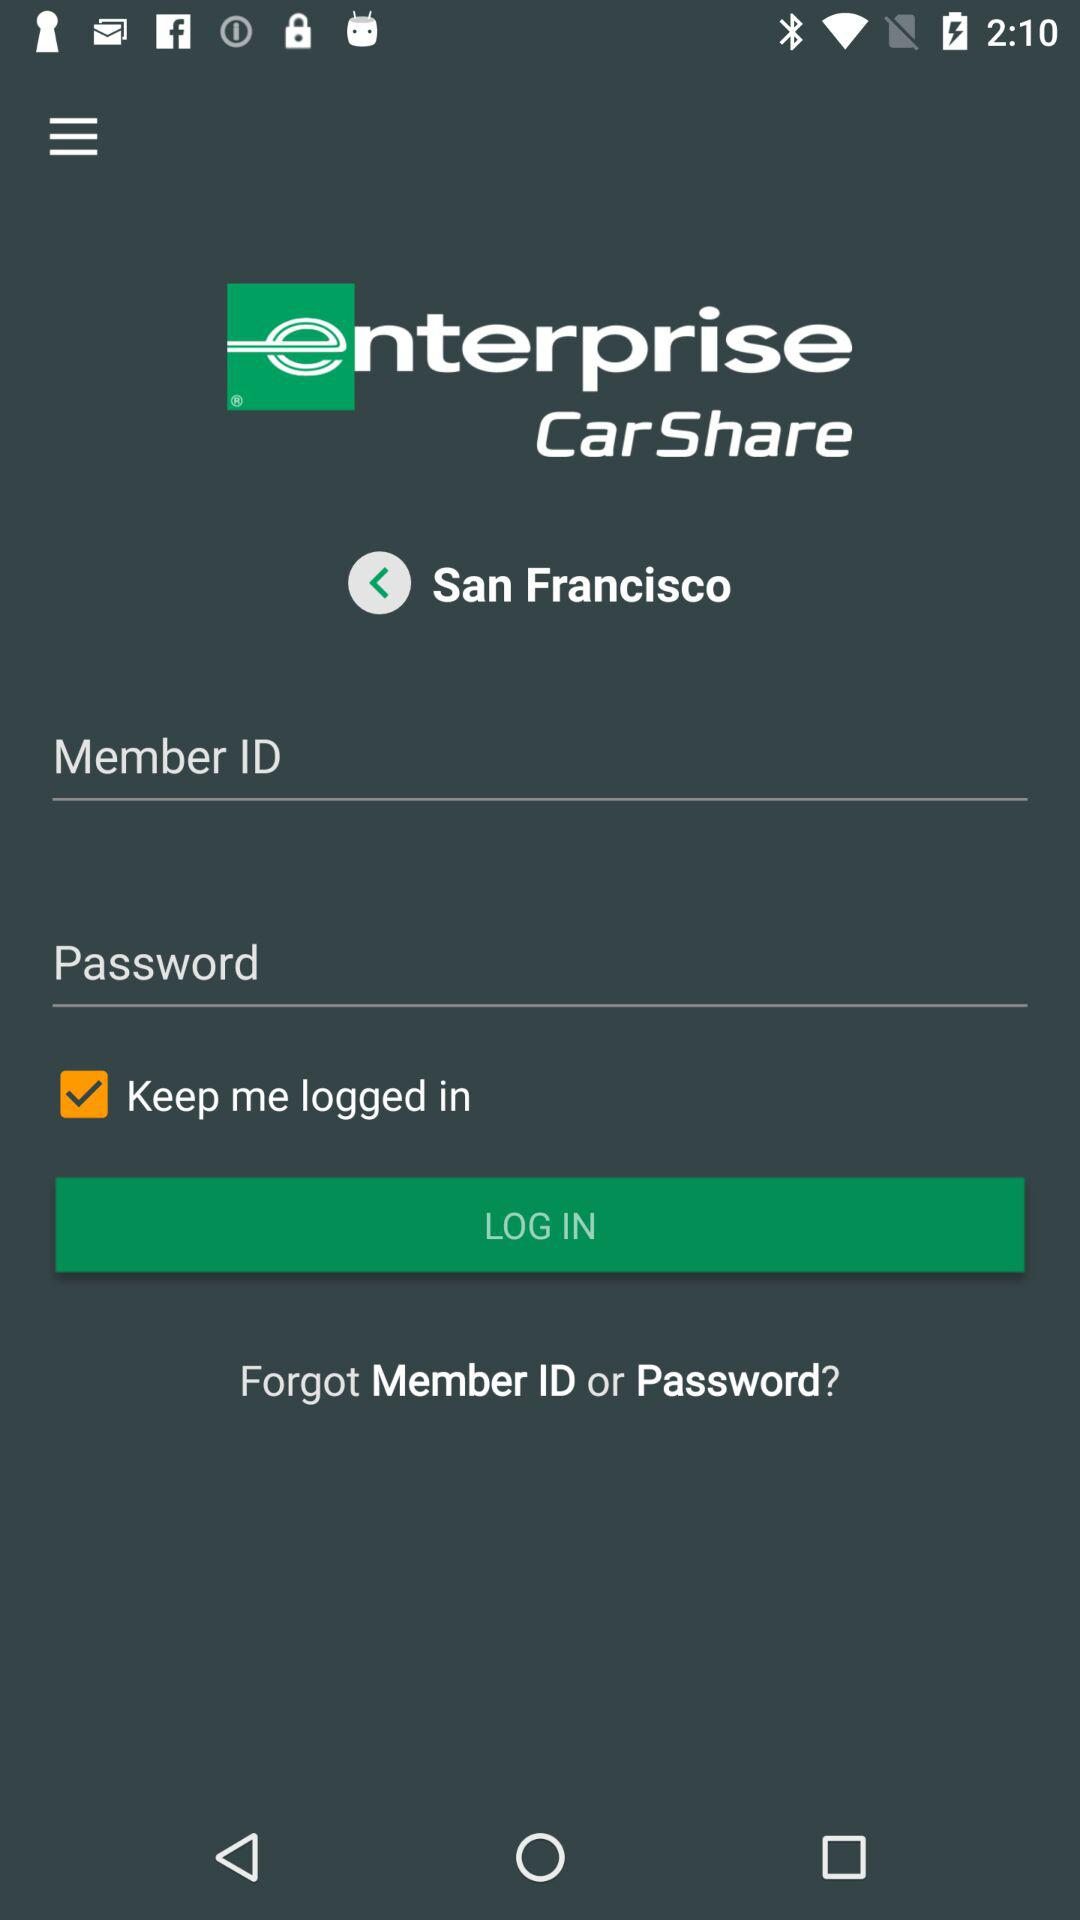What is the application name? The application name is "enterprise CarShare". 